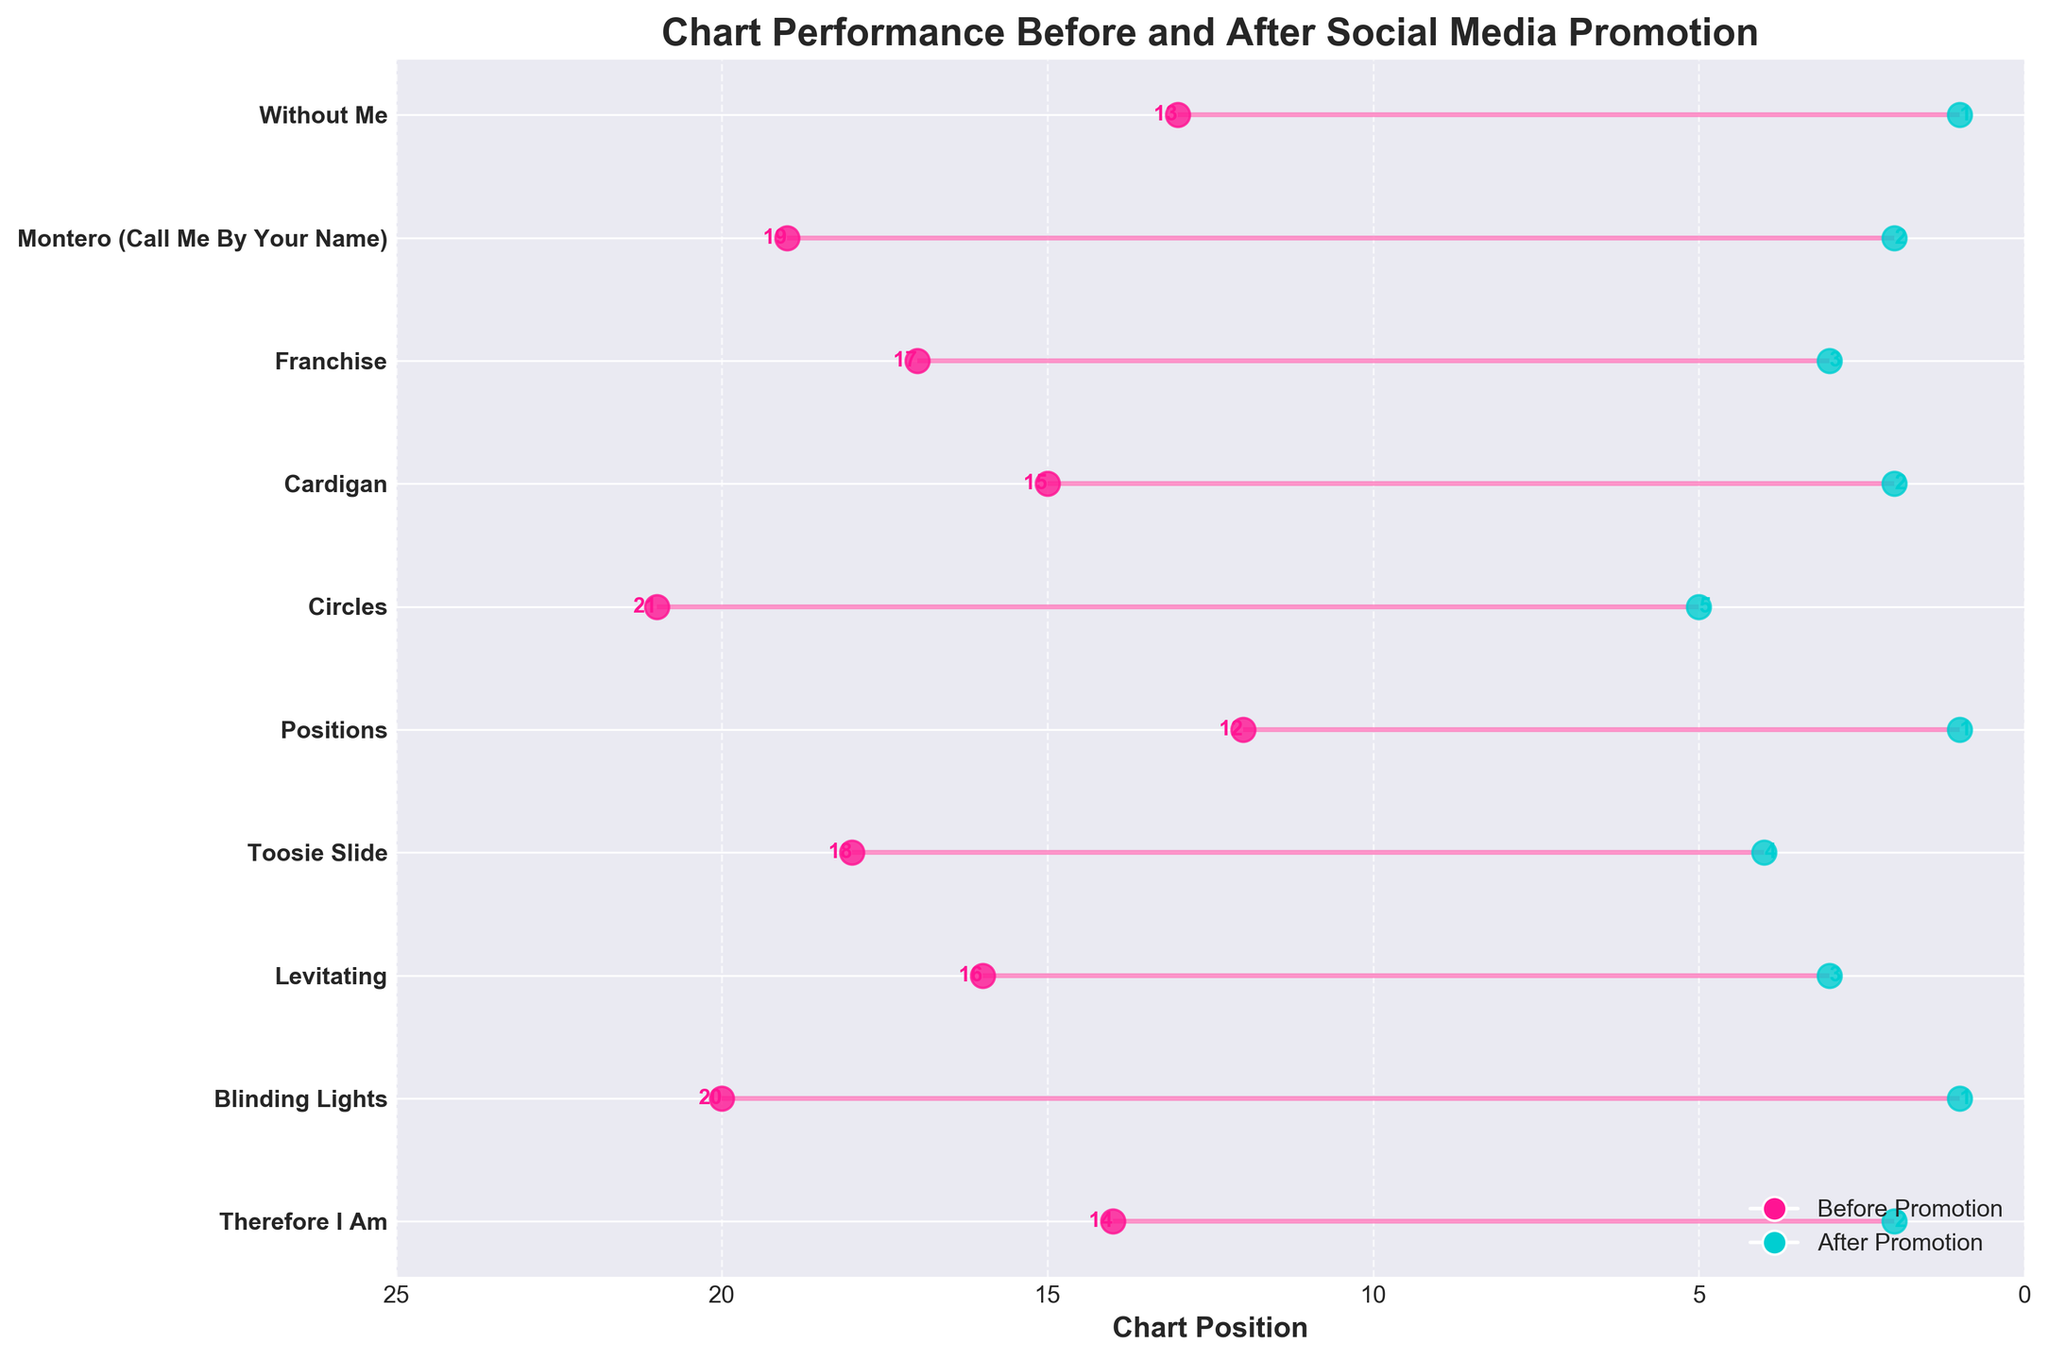What's the title of the plot? The title is displayed at the top of the plot. It provides a summary of what the plot is about. The text at the top reads "Chart Performance Before and After Social Media Promotion."
Answer: Chart Performance Before and After Social Media Promotion How many singles are illustrated in the plot? You can count the number of lines or dots corresponding to each single. Each line represents a single. Counting down the y-axis gives a total of 10 entries.
Answer: 10 Which single had the highest chart improvement after promotion? The highest improvement can be deduced by finding the single with the most significant change in its chart position. "Blinding Lights" by The Weeknd moved from position 20 to position 1.
Answer: Blinding Lights Which single showed the least improvement after promotion? This can be identified by looking at the line with the smallest change in chart positions. "Circles" by Post Malone moved from position 21 to position 5, which is the smallest improvement.
Answer: Circles What is the average chart position before promotion? To find the average, sum all the positions before promotion and divide by the number of singles: (14 + 20 + 16 + 18 + 12 + 21 + 15 + 17 + 19 + 13) / 10. This calculation gives an average of 16.5.
Answer: 16.5 What is the median chart position after promotion? To find the median, first list the after-promotion positions in ascending order: 1, 1, 1, 2, 2, 2, 3, 3, 4, 5. The median is the middle value, or the average of the two middle values if the list length is even. The median here is 2.
Answer: 2 How many singles reached the number 1 chart position after promotion? By examining the "Week After Promotion" column, count how many entries have the value 1. The singles "Blinding Lights," "Positions," and "Without Me" reached 1, making a total of 3.
Answer: 3 Which singles had their position improved to rank 2 after promotion? Look at the "Week After Promotion" and find entries with the value 2. "Therefore I Am," "Cardigan," and "Montero (Call Me By Your Name)" are these singles.
Answer: Therefore I Am, Cardigan, Montero (Call Me By Your Name) Which artist achieved the largest improvement in chart position due to promotion? Comparing the before and after positions, find the single with the most significant downward shift (which represents improvement). "Blinding Lights" improved from 20 to 1, a difference of 19.
Answer: The Weeknd Order the singles by their chart position improvement after social media promotion, from highest to lowest. Calculate the change for each single and then rank them. 
1. Blinding Lights (19)
2. Therefore I Am (12)
3. Positions (11)
4. Cardigan (13)
5. Montero (Call Me By Your Name) (17)
6. Without Me (12)
7. Levitating (13)
8. Franchise (14)
9. Toosie Slide (14)
10. Circles (16)
Answer: Blinding Lights, Therefore I Am, Positions, Cardigan, Montero (Call Me By Your Name), Without Me, Levitating, Franchise, Toosie Slide, Circles 